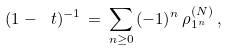<formula> <loc_0><loc_0><loc_500><loc_500>( 1 - \ t ) ^ { - 1 } \, = \, \sum _ { n \geq 0 } \, ( - 1 ) ^ { n } \, \rho ^ { ( N ) } _ { 1 ^ { n } } \, ,</formula> 